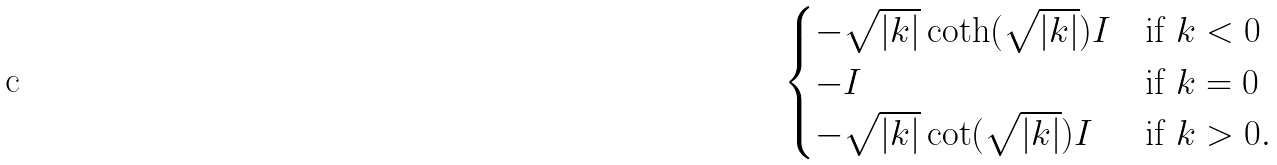Convert formula to latex. <formula><loc_0><loc_0><loc_500><loc_500>\begin{cases} - \sqrt { | k | } \coth ( \sqrt { | k | } ) I & \text {if } k < 0 \\ - I & \text {if } k = 0 \\ - \sqrt { | k | } \cot ( \sqrt { | k | } ) I & \text {if } k > 0 . \end{cases}</formula> 